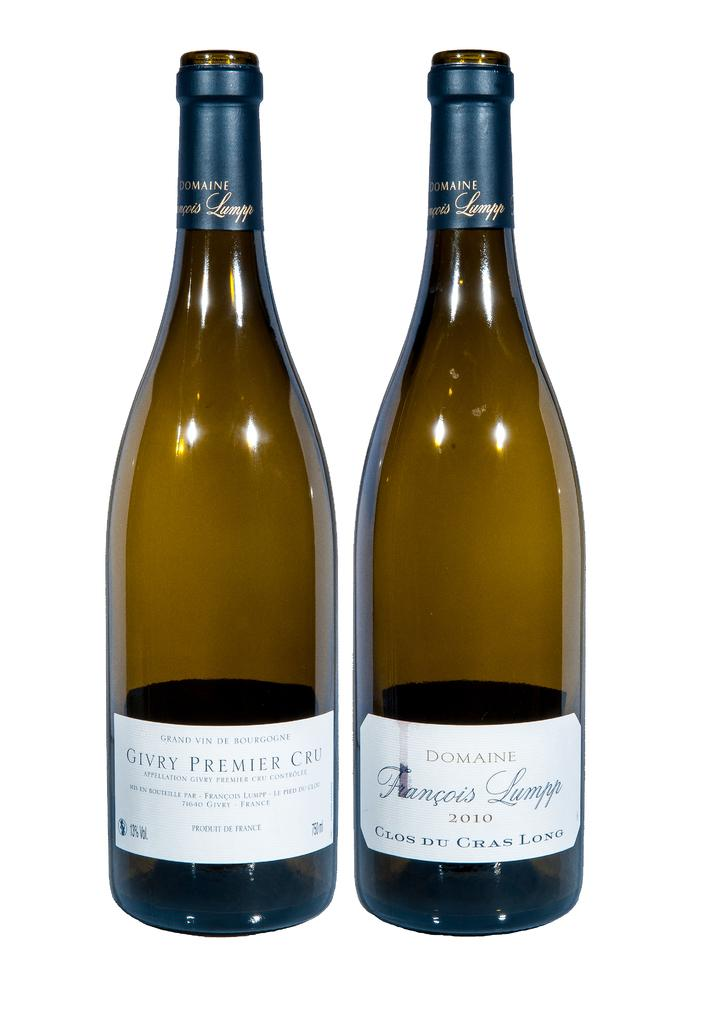<image>
Create a compact narrative representing the image presented. A bottle of Givry Premier Cru wine sits next to another bottle of wine. 